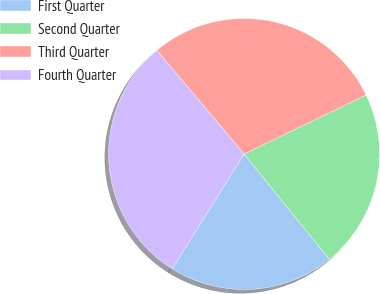Convert chart to OTSL. <chart><loc_0><loc_0><loc_500><loc_500><pie_chart><fcel>First Quarter<fcel>Second Quarter<fcel>Third Quarter<fcel>Fourth Quarter<nl><fcel>19.74%<fcel>21.34%<fcel>28.97%<fcel>29.95%<nl></chart> 